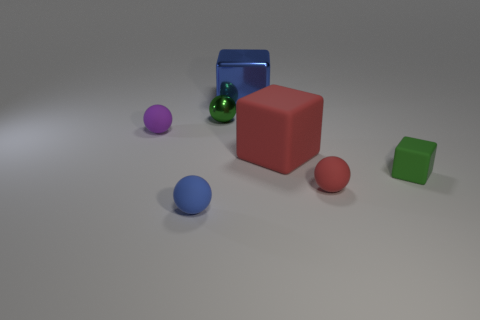Subtract 1 balls. How many balls are left? 3 Add 2 purple matte objects. How many objects exist? 9 Subtract all cubes. How many objects are left? 4 Add 7 small purple spheres. How many small purple spheres are left? 8 Add 2 rubber cubes. How many rubber cubes exist? 4 Subtract 1 green spheres. How many objects are left? 6 Subtract all tiny cyan rubber cylinders. Subtract all purple rubber balls. How many objects are left? 6 